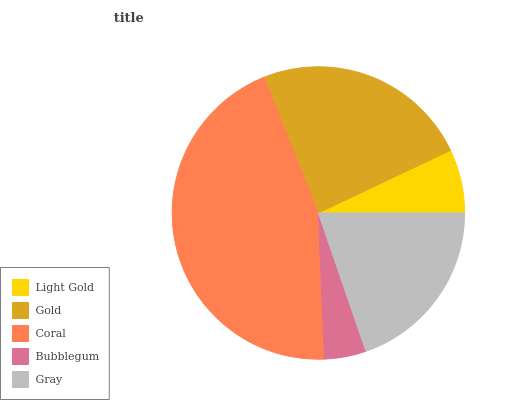Is Bubblegum the minimum?
Answer yes or no. Yes. Is Coral the maximum?
Answer yes or no. Yes. Is Gold the minimum?
Answer yes or no. No. Is Gold the maximum?
Answer yes or no. No. Is Gold greater than Light Gold?
Answer yes or no. Yes. Is Light Gold less than Gold?
Answer yes or no. Yes. Is Light Gold greater than Gold?
Answer yes or no. No. Is Gold less than Light Gold?
Answer yes or no. No. Is Gray the high median?
Answer yes or no. Yes. Is Gray the low median?
Answer yes or no. Yes. Is Coral the high median?
Answer yes or no. No. Is Coral the low median?
Answer yes or no. No. 